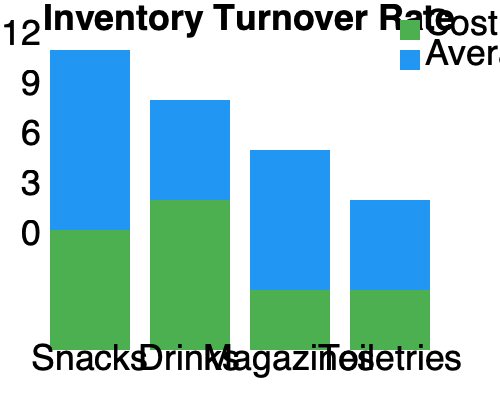Based on the stacked bar chart showing inventory turnover rates for different product lines in your local shop, which product category has the highest inventory turnover rate? To determine the product category with the highest inventory turnover rate, we need to analyze the chart and understand what it represents:

1. The chart shows four product categories: Snacks, Drinks, Magazines, and Toiletries.

2. For each category, there are two stacked bars:
   - The blue bar represents the Average Inventory
   - The green bar represents the Cost of Goods Sold (COGS)

3. The inventory turnover rate is calculated by dividing COGS by Average Inventory:

   $$ \text{Inventory Turnover Rate} = \frac{\text{Cost of Goods Sold}}{\text{Average Inventory}} $$

4. In the chart, the total height of each stacked bar represents the inventory turnover rate.

5. Comparing the total heights of the stacked bars:
   - Snacks: Highest bar, reaching about 12 on the y-axis
   - Drinks: Second highest, reaching about 9
   - Magazines: Third, reaching about 7
   - Toiletries: Lowest, reaching about 5

6. The higher the bar, the higher the inventory turnover rate.

Therefore, the product category with the highest inventory turnover rate is Snacks.
Answer: Snacks 